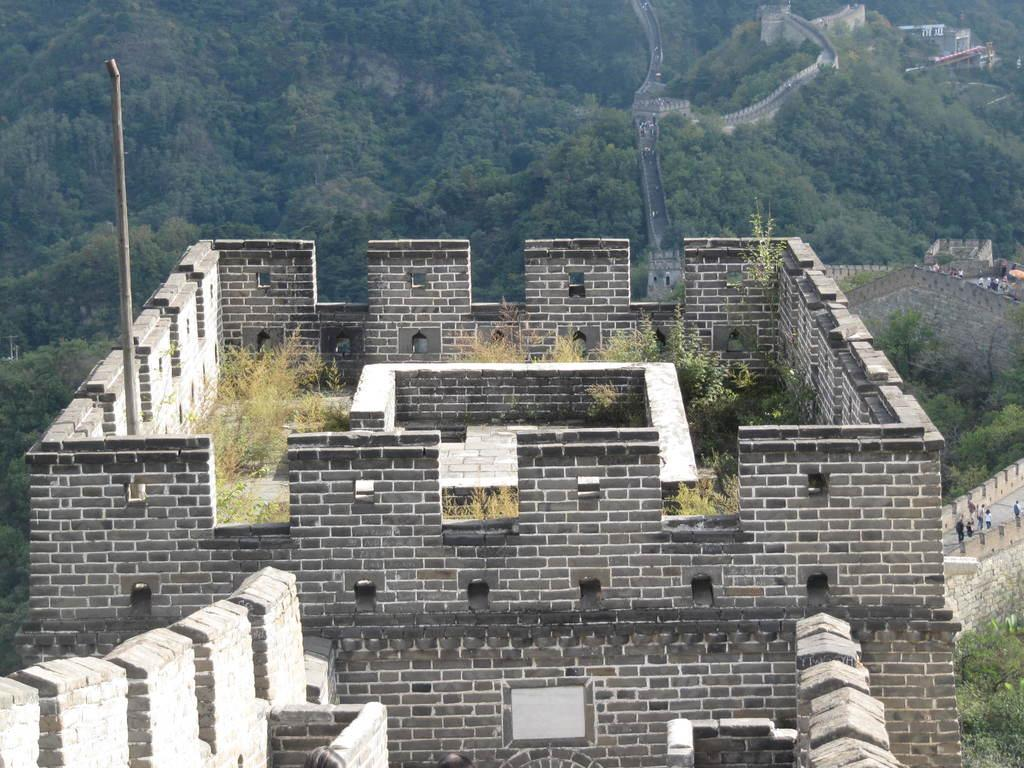What famous landmark can be seen in the image? The Great Wall of China is visible in the image. What are the people in the image doing? There are people standing on the path of the Great Wall of China. What type of vegetation is visible behind the Great Wall of China? There are trees behind the Great Wall of China. Can you see any clover growing near the Great Wall of China in the image? There is no clover visible in the image. Is there a library located on the Great Wall of China in the image? There is no library visible in the image. 